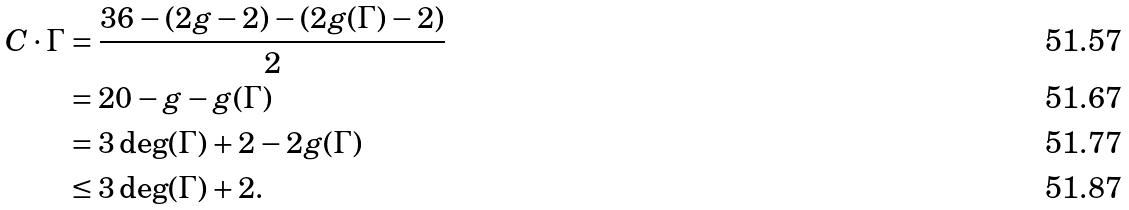Convert formula to latex. <formula><loc_0><loc_0><loc_500><loc_500>C \cdot \Gamma & = \frac { 3 6 - ( 2 g - 2 ) - ( 2 g ( \Gamma ) - 2 ) } { 2 } \\ & = 2 0 - g - g ( \Gamma ) \\ & = 3 \deg ( \Gamma ) + 2 - 2 g ( \Gamma ) \\ & \leq 3 \deg ( \Gamma ) + 2 .</formula> 